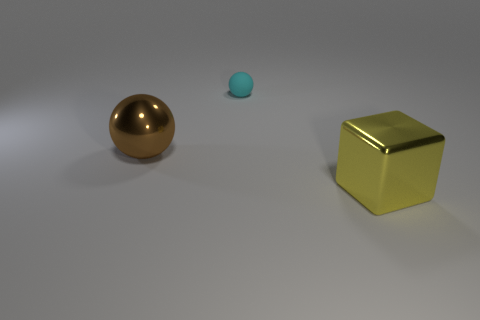Add 3 tiny blue rubber cubes. How many objects exist? 6 Subtract all cubes. How many objects are left? 2 Add 1 large brown shiny balls. How many large brown shiny balls exist? 2 Subtract 0 purple cylinders. How many objects are left? 3 Subtract all yellow things. Subtract all cyan spheres. How many objects are left? 1 Add 1 cyan matte things. How many cyan matte things are left? 2 